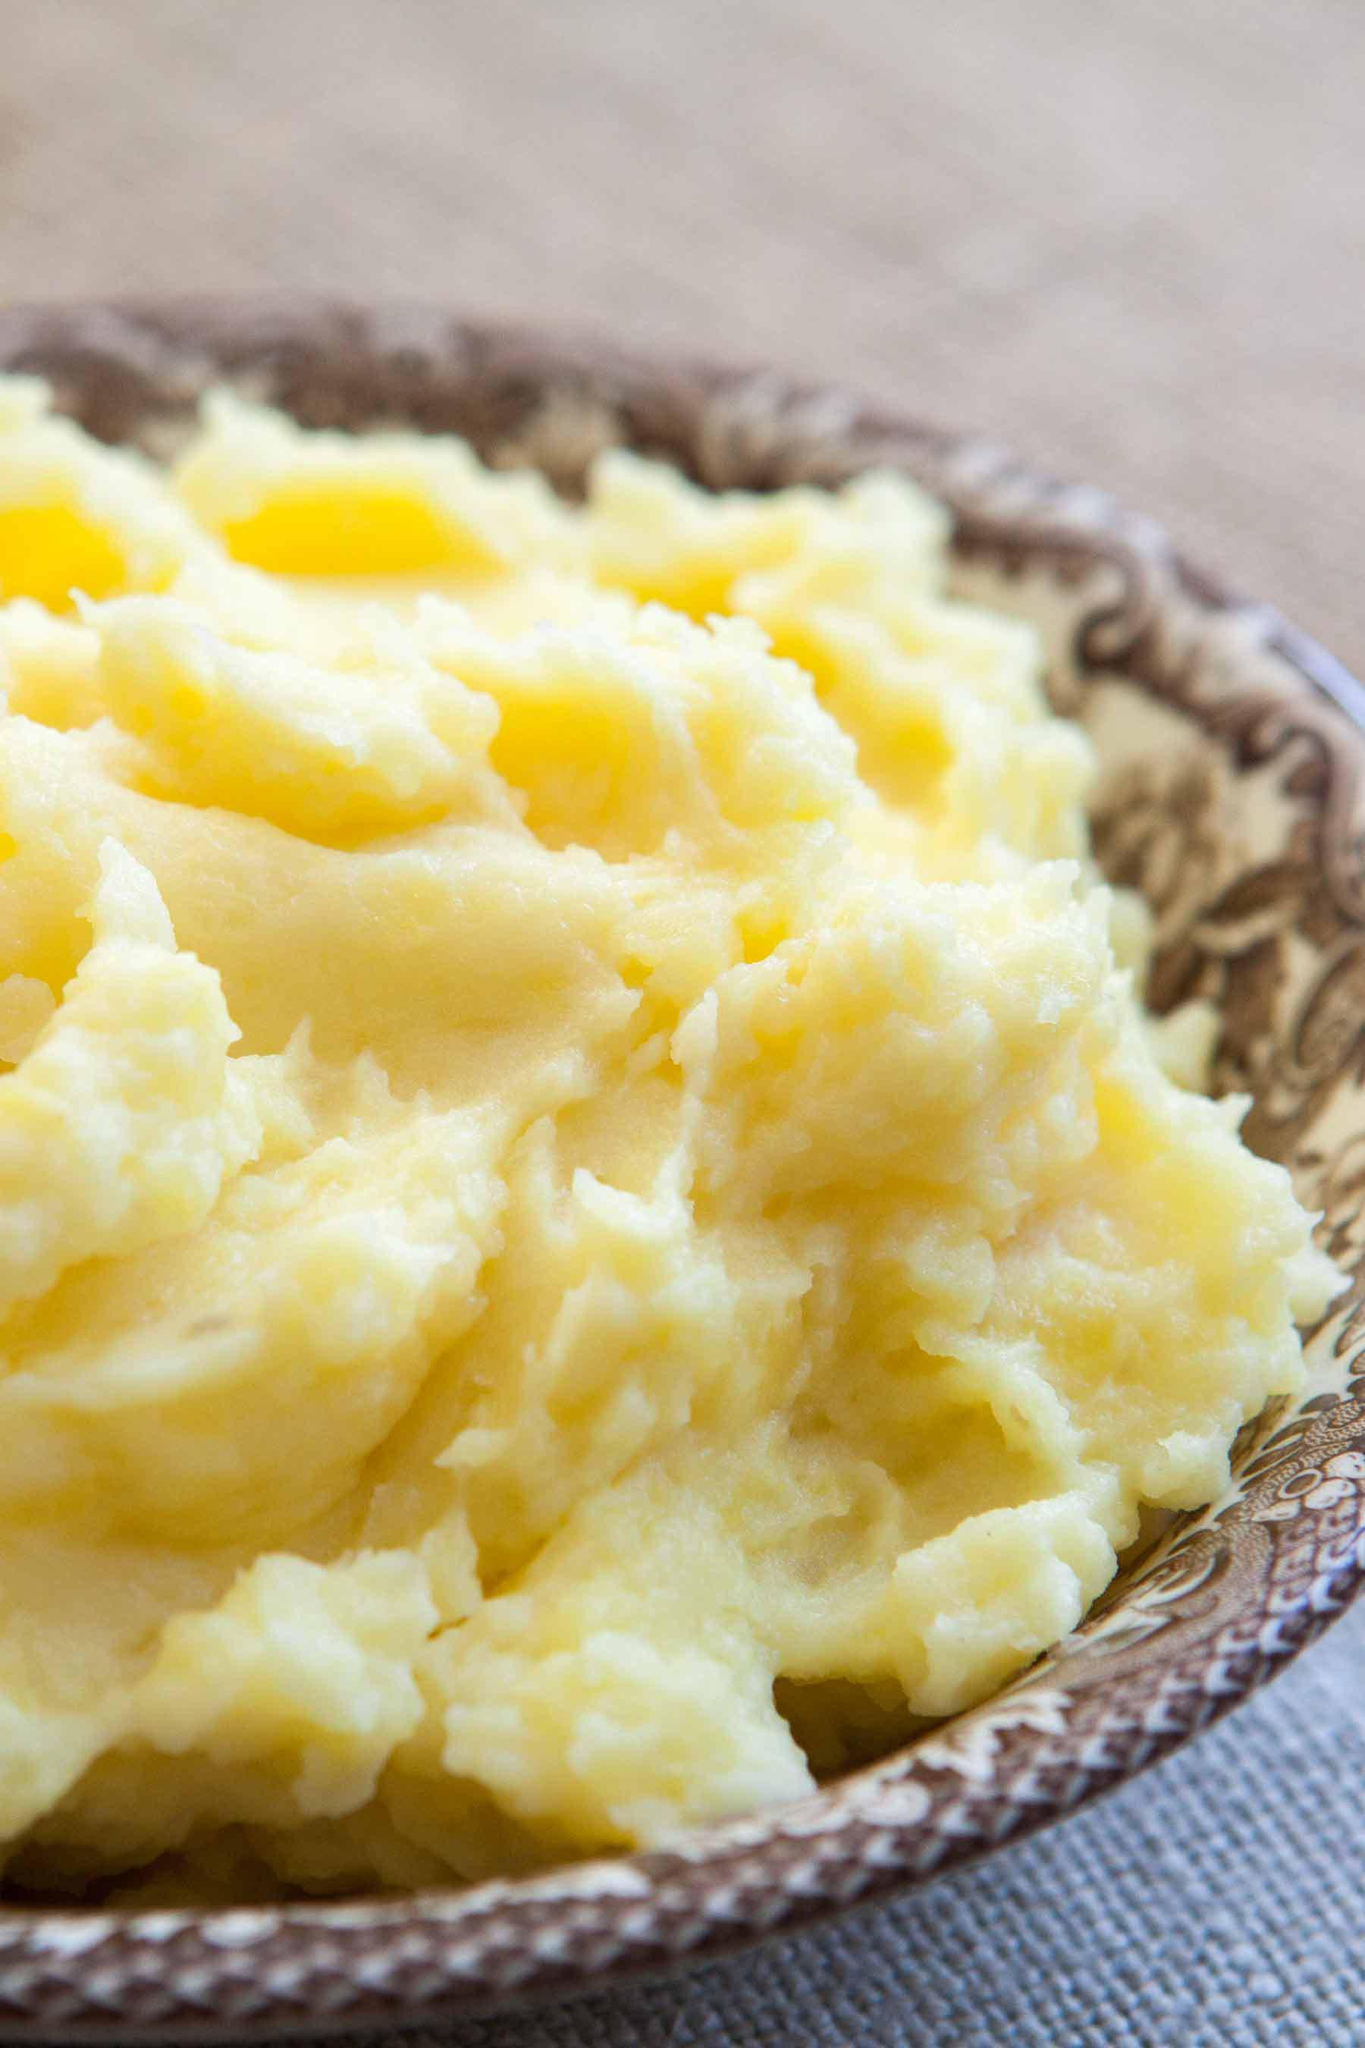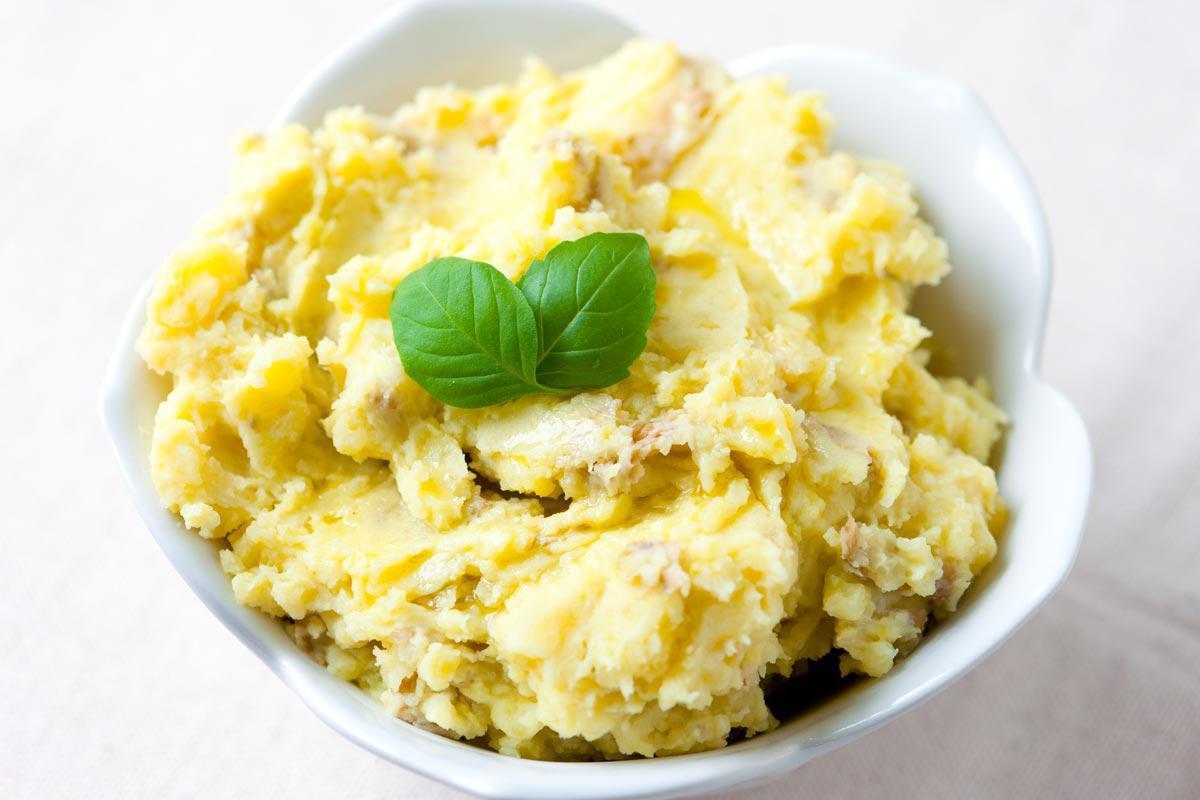The first image is the image on the left, the second image is the image on the right. Analyze the images presented: Is the assertion "One imagine in the pair has a slab of butter visible in the mashed potato." valid? Answer yes or no. No. 